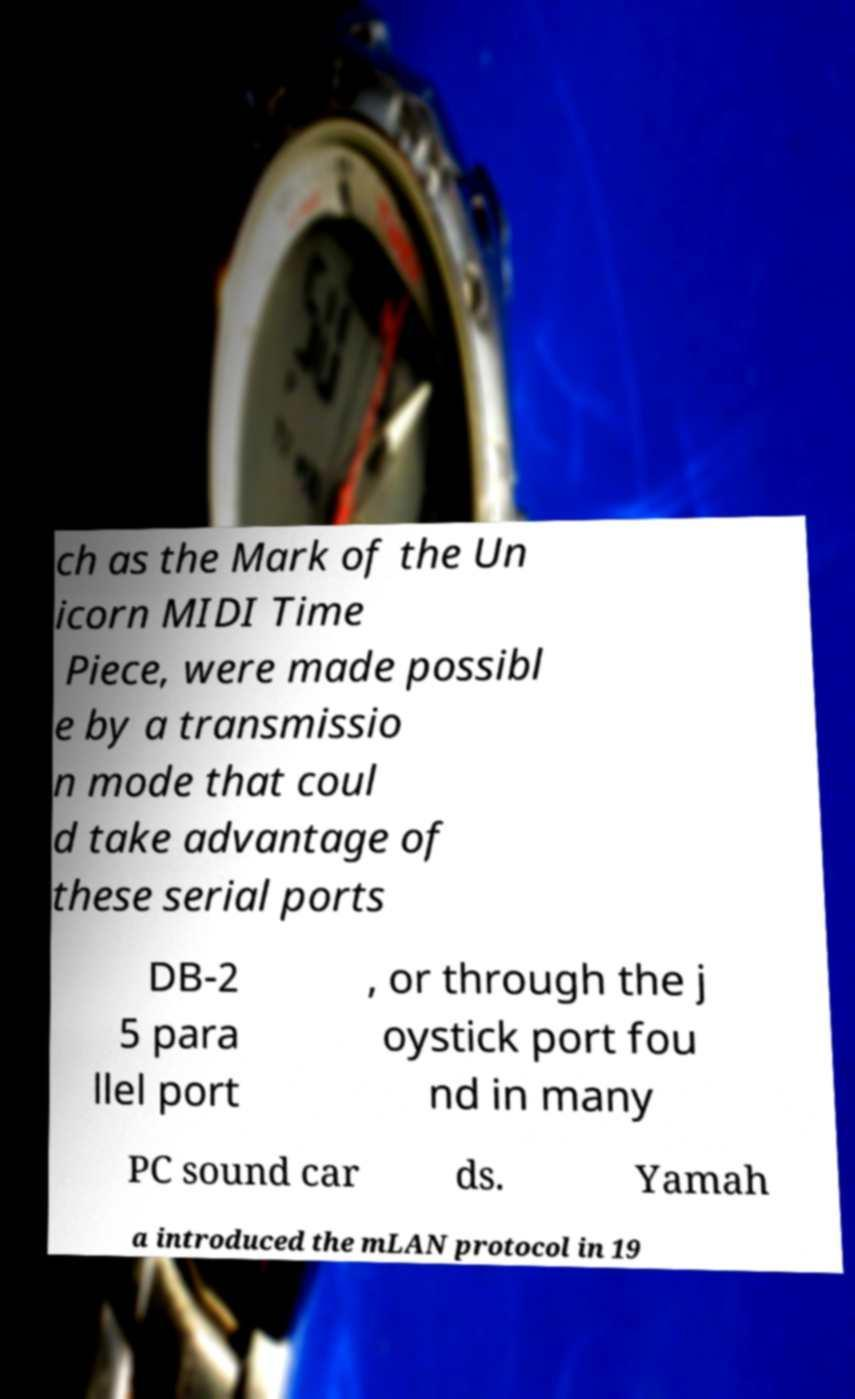Could you extract and type out the text from this image? ch as the Mark of the Un icorn MIDI Time Piece, were made possibl e by a transmissio n mode that coul d take advantage of these serial ports DB-2 5 para llel port , or through the j oystick port fou nd in many PC sound car ds. Yamah a introduced the mLAN protocol in 19 